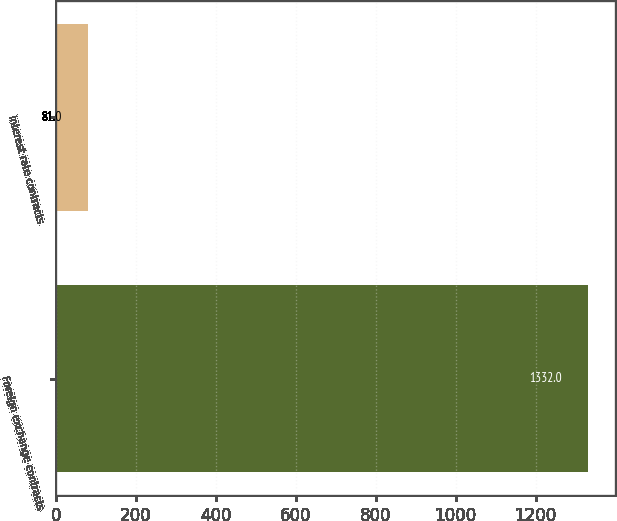<chart> <loc_0><loc_0><loc_500><loc_500><bar_chart><fcel>Foreign exchange contracts<fcel>Interest rate contracts<nl><fcel>1332<fcel>81<nl></chart> 